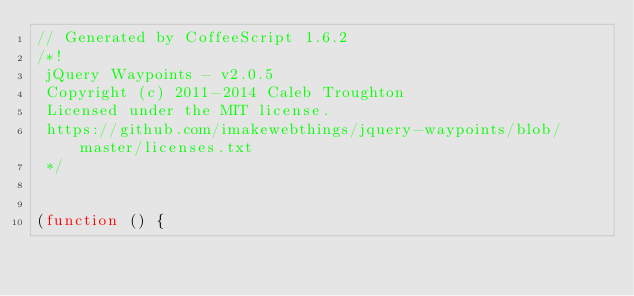Convert code to text. <code><loc_0><loc_0><loc_500><loc_500><_JavaScript_>// Generated by CoffeeScript 1.6.2
/*!
 jQuery Waypoints - v2.0.5
 Copyright (c) 2011-2014 Caleb Troughton
 Licensed under the MIT license.
 https://github.com/imakewebthings/jquery-waypoints/blob/master/licenses.txt
 */


(function () {</code> 